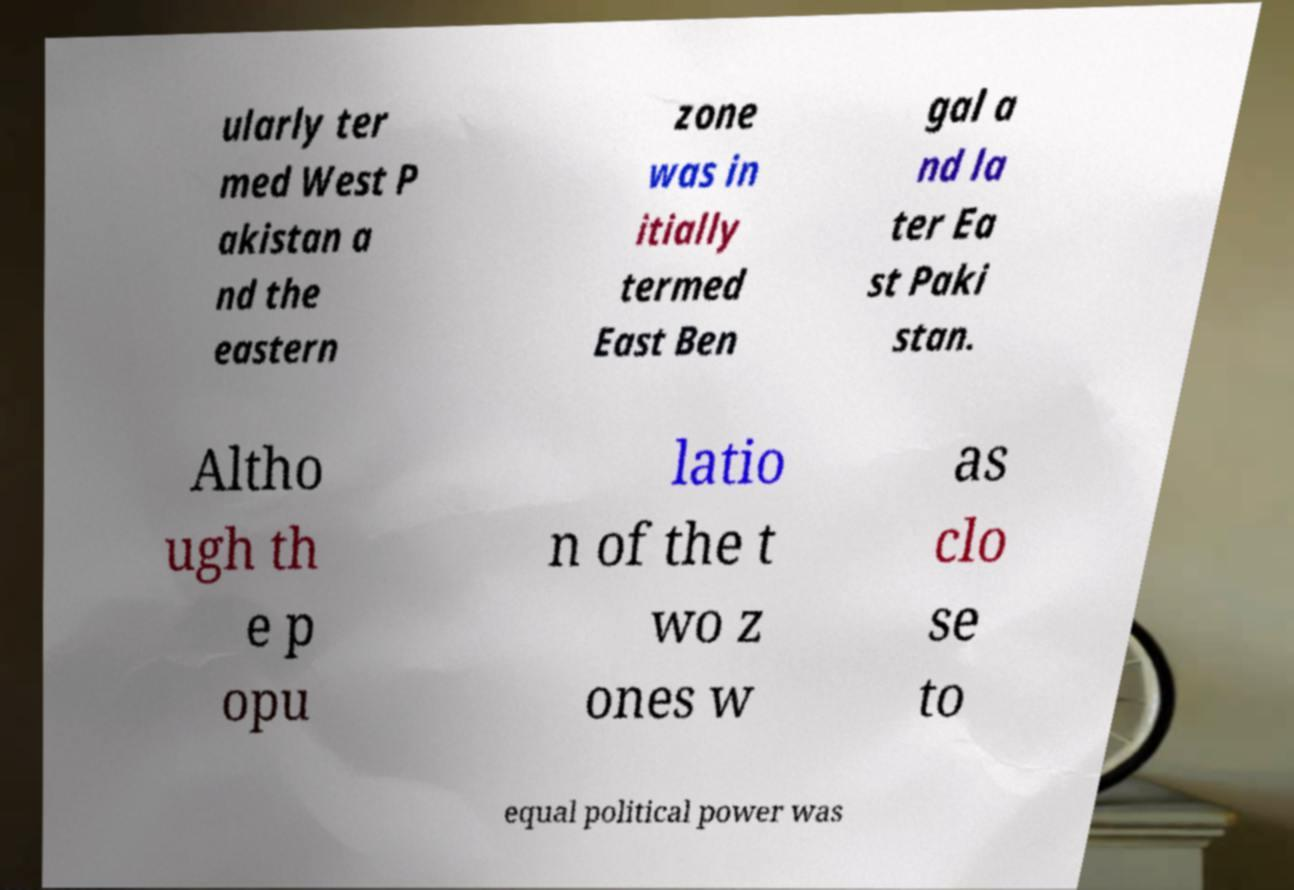There's text embedded in this image that I need extracted. Can you transcribe it verbatim? ularly ter med West P akistan a nd the eastern zone was in itially termed East Ben gal a nd la ter Ea st Paki stan. Altho ugh th e p opu latio n of the t wo z ones w as clo se to equal political power was 